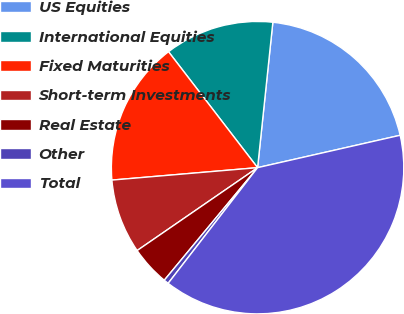Convert chart. <chart><loc_0><loc_0><loc_500><loc_500><pie_chart><fcel>US Equities<fcel>International Equities<fcel>Fixed Maturities<fcel>Short-term Investments<fcel>Real Estate<fcel>Other<fcel>Total<nl><fcel>19.78%<fcel>12.09%<fcel>15.93%<fcel>8.24%<fcel>4.39%<fcel>0.54%<fcel>39.03%<nl></chart> 